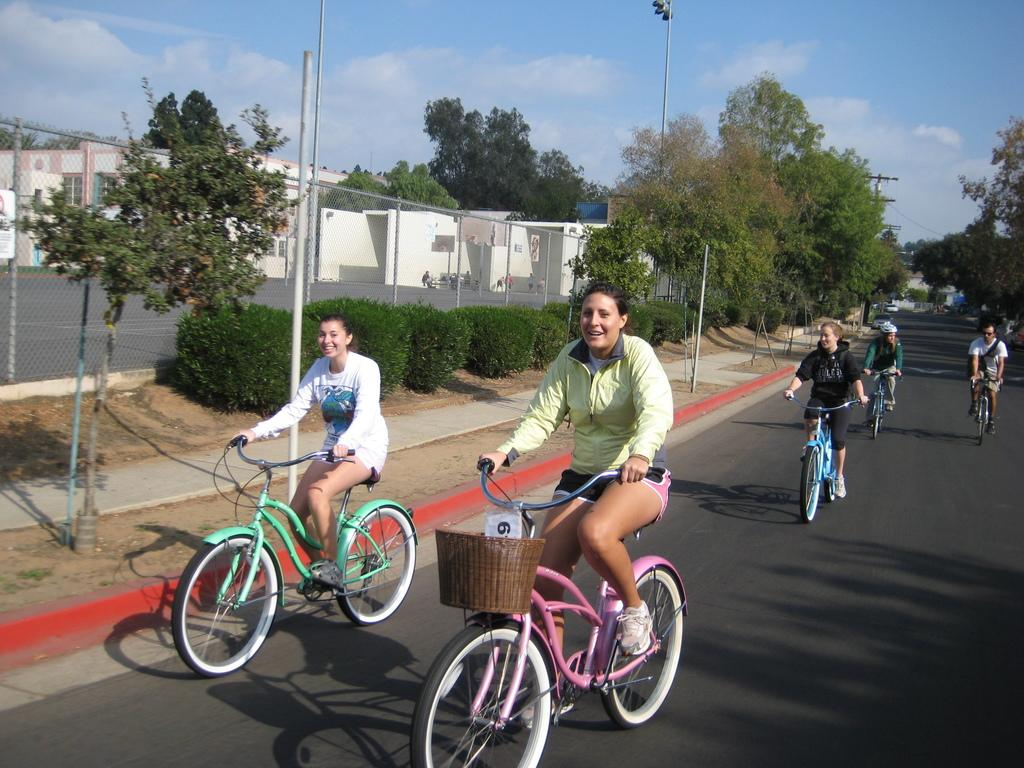What are the girls doing in the image? The girls are riding bicycles in the image. Where are the girls riding their bicycles? The girls are on a road in the image. What can be seen on either side of the road? There are trees on either side of the road. What other feature can be seen on the left side of the image? There is a basketball court on the left side of the image. What is visible in the sky in the image? The sky is visible in the image, and clouds are present. What type of stove can be seen in the image? There is no stove present in the image. How many ice cubes are visible in the image? There are no ice cubes visible in the image. 